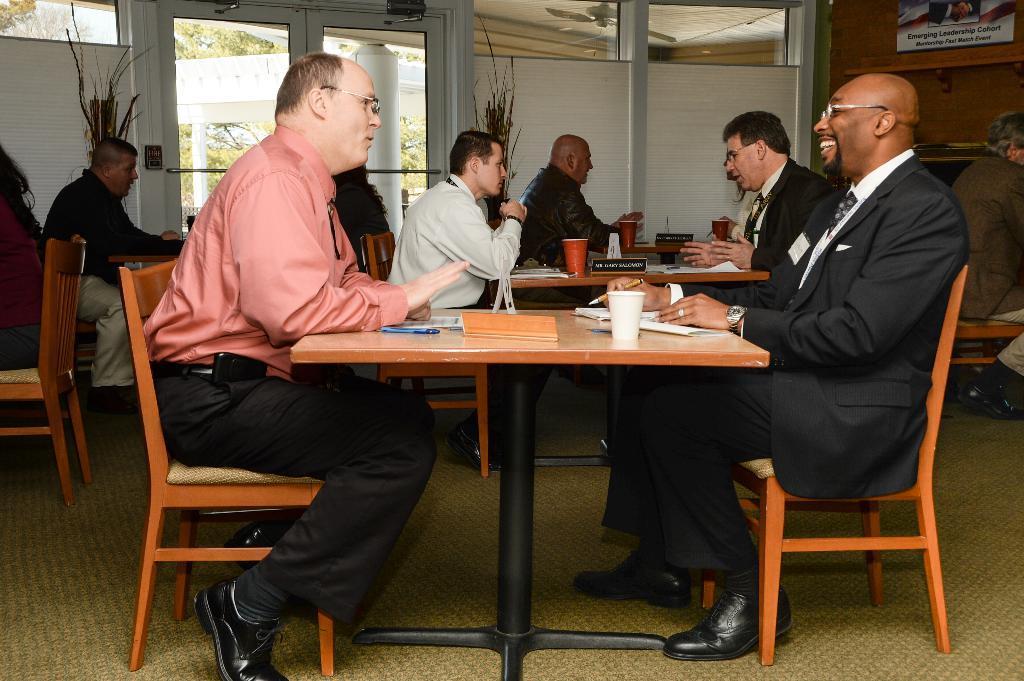In one or two sentences, can you explain what this image depicts? In this image I can see the group of people sitting in-front of the table. On the table there are papers and the cup. In the background there is a board and the glass door. Through the glass we can see some trees. 